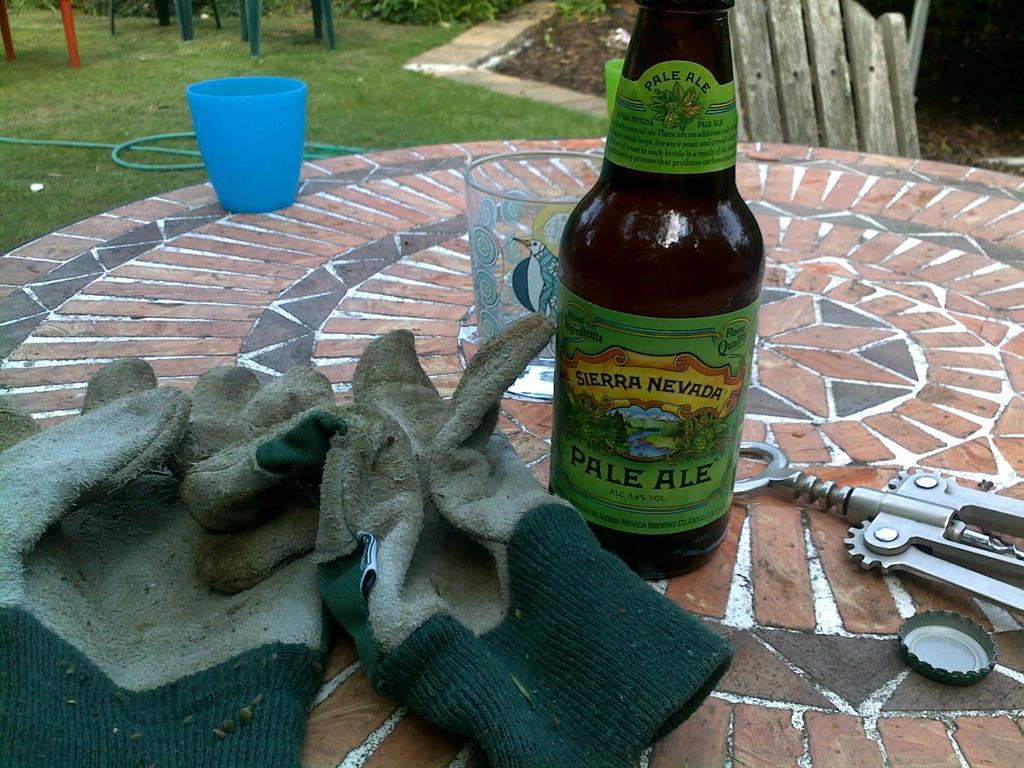What type of vegetation can be seen in the image? There is grass in the image. What man-made object is present in the image? There is a water pipe in the image. What items are used for holding liquids in the image? There is a bottle and a glass in the image. What color is the object in the image? There is a blue object in the image. What part of the bottle is visible in the image? The bottle cap is visible in the image. What type of object can be seen in the distance? There is a wooden object in the distance. How many giants are present in the image? There are no giants present in the image. What type of sock is visible on the grass? There is no sock visible in the image. 